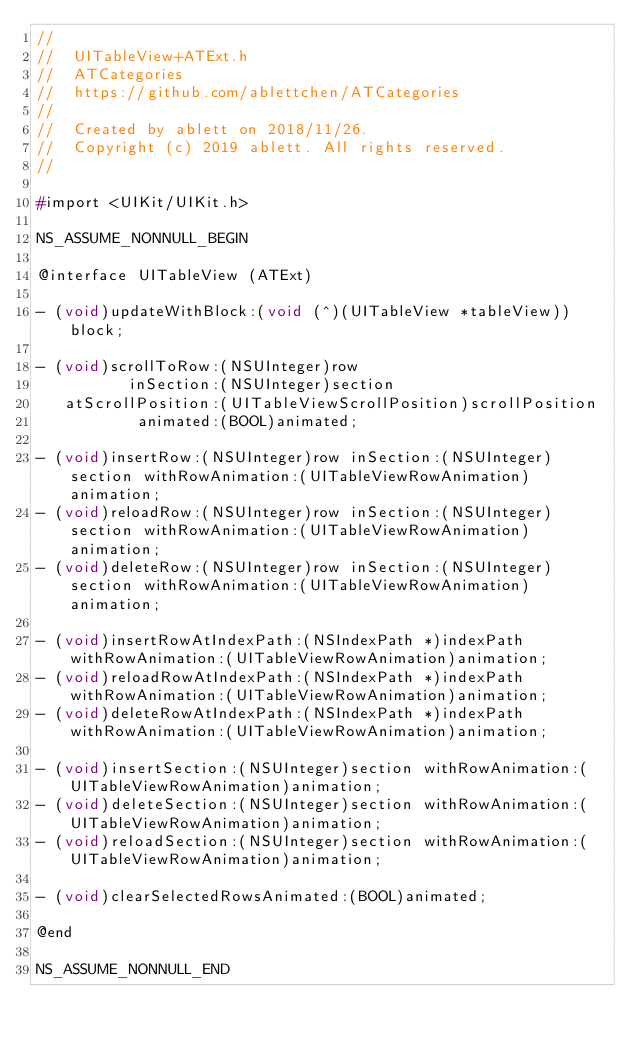<code> <loc_0><loc_0><loc_500><loc_500><_C_>//
//  UITableView+ATExt.h
//  ATCategories
//  https://github.com/ablettchen/ATCategories
//
//  Created by ablett on 2018/11/26.
//  Copyright (c) 2019 ablett. All rights reserved.
//

#import <UIKit/UIKit.h>

NS_ASSUME_NONNULL_BEGIN

@interface UITableView (ATExt)

- (void)updateWithBlock:(void (^)(UITableView *tableView))block;

- (void)scrollToRow:(NSUInteger)row
          inSection:(NSUInteger)section
   atScrollPosition:(UITableViewScrollPosition)scrollPosition
           animated:(BOOL)animated;

- (void)insertRow:(NSUInteger)row inSection:(NSUInteger)section withRowAnimation:(UITableViewRowAnimation)animation;
- (void)reloadRow:(NSUInteger)row inSection:(NSUInteger)section withRowAnimation:(UITableViewRowAnimation)animation;
- (void)deleteRow:(NSUInteger)row inSection:(NSUInteger)section withRowAnimation:(UITableViewRowAnimation)animation;

- (void)insertRowAtIndexPath:(NSIndexPath *)indexPath withRowAnimation:(UITableViewRowAnimation)animation;
- (void)reloadRowAtIndexPath:(NSIndexPath *)indexPath withRowAnimation:(UITableViewRowAnimation)animation;
- (void)deleteRowAtIndexPath:(NSIndexPath *)indexPath withRowAnimation:(UITableViewRowAnimation)animation;

- (void)insertSection:(NSUInteger)section withRowAnimation:(UITableViewRowAnimation)animation;
- (void)deleteSection:(NSUInteger)section withRowAnimation:(UITableViewRowAnimation)animation;
- (void)reloadSection:(NSUInteger)section withRowAnimation:(UITableViewRowAnimation)animation;

- (void)clearSelectedRowsAnimated:(BOOL)animated;

@end

NS_ASSUME_NONNULL_END
</code> 